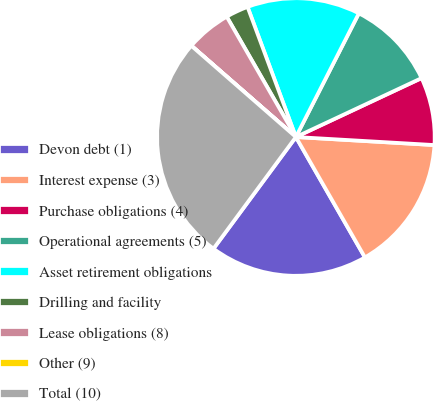<chart> <loc_0><loc_0><loc_500><loc_500><pie_chart><fcel>Devon debt (1)<fcel>Interest expense (3)<fcel>Purchase obligations (4)<fcel>Operational agreements (5)<fcel>Asset retirement obligations<fcel>Drilling and facility<fcel>Lease obligations (8)<fcel>Other (9)<fcel>Total (10)<nl><fcel>18.41%<fcel>15.79%<fcel>7.9%<fcel>10.53%<fcel>13.16%<fcel>2.64%<fcel>5.27%<fcel>0.01%<fcel>26.3%<nl></chart> 